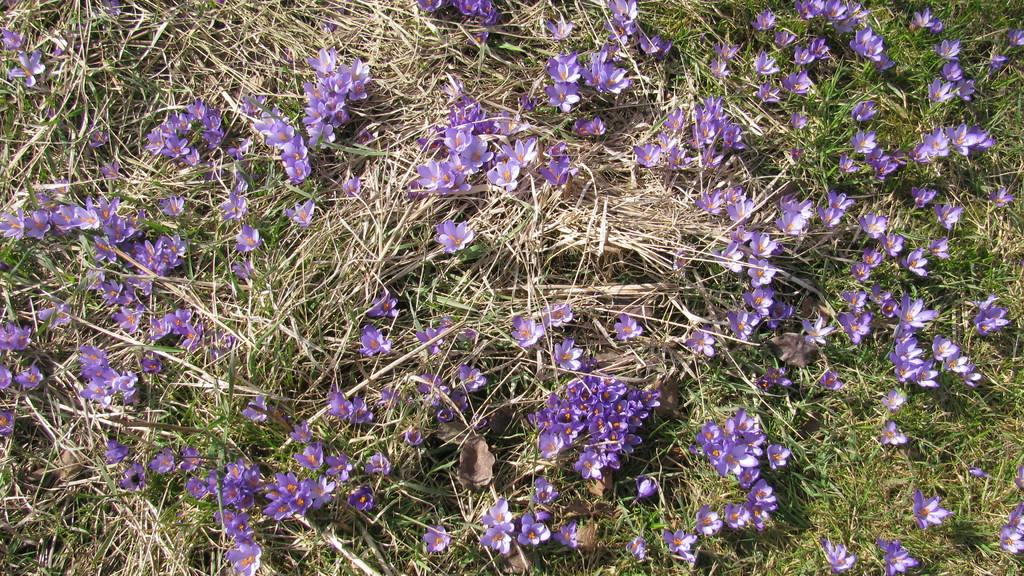What type of plants can be seen in the image? There are flowers in the image. What else can be seen in the image besides flowers? There is grass in the image. What type of joke is being told by the flowers in the image? There is no indication in the image that the flowers are telling a joke, as plants do not have the ability to speak or tell jokes. 